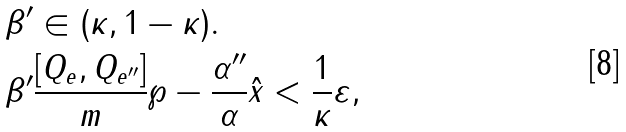Convert formula to latex. <formula><loc_0><loc_0><loc_500><loc_500>& \beta ^ { \prime } \in ( \kappa , 1 - \kappa ) . \\ & \beta ^ { \prime } \frac { [ Q _ { e } , Q _ { e ^ { \prime \prime } } ] } { m } \wp - \frac { \alpha ^ { \prime \prime } } { \alpha } \hat { x } < \frac { 1 } { \kappa } \varepsilon ,</formula> 